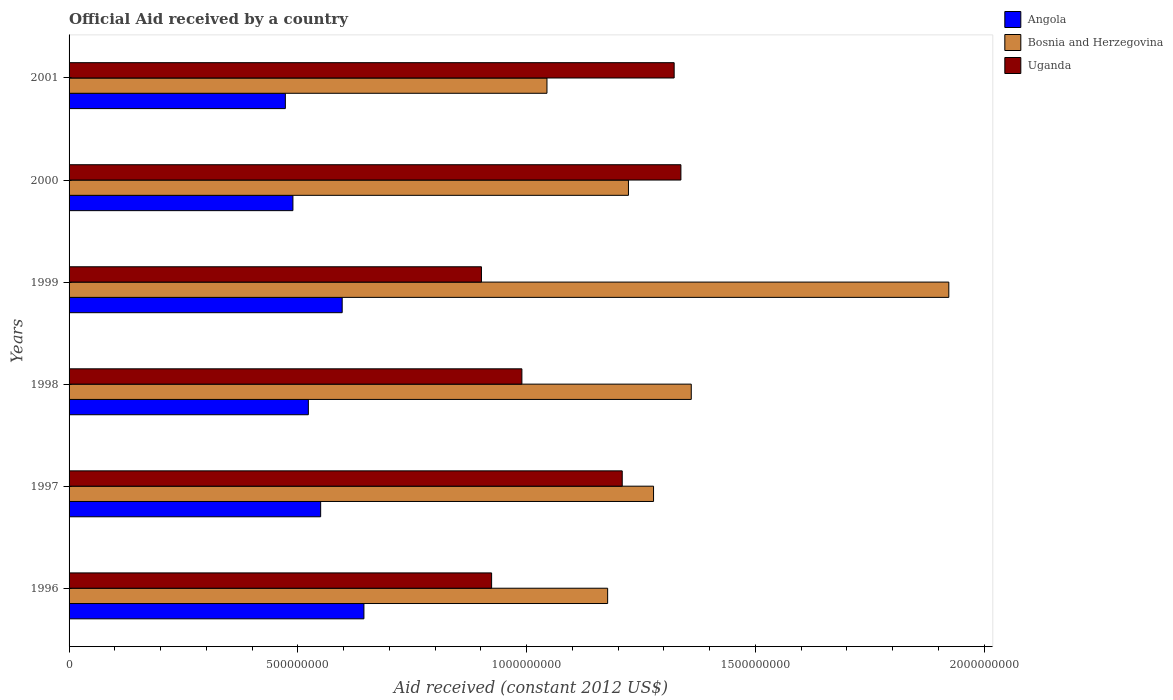How many different coloured bars are there?
Give a very brief answer. 3. How many groups of bars are there?
Keep it short and to the point. 6. Are the number of bars on each tick of the Y-axis equal?
Offer a terse response. Yes. What is the label of the 2nd group of bars from the top?
Your answer should be compact. 2000. What is the net official aid received in Bosnia and Herzegovina in 2001?
Your answer should be compact. 1.04e+09. Across all years, what is the maximum net official aid received in Uganda?
Your answer should be very brief. 1.34e+09. Across all years, what is the minimum net official aid received in Angola?
Give a very brief answer. 4.73e+08. In which year was the net official aid received in Bosnia and Herzegovina maximum?
Provide a succinct answer. 1999. What is the total net official aid received in Uganda in the graph?
Ensure brevity in your answer.  6.68e+09. What is the difference between the net official aid received in Uganda in 1996 and that in 2000?
Make the answer very short. -4.14e+08. What is the difference between the net official aid received in Bosnia and Herzegovina in 2000 and the net official aid received in Uganda in 1998?
Offer a terse response. 2.33e+08. What is the average net official aid received in Bosnia and Herzegovina per year?
Keep it short and to the point. 1.33e+09. In the year 1998, what is the difference between the net official aid received in Uganda and net official aid received in Bosnia and Herzegovina?
Your response must be concise. -3.70e+08. In how many years, is the net official aid received in Bosnia and Herzegovina greater than 900000000 US$?
Provide a short and direct response. 6. What is the ratio of the net official aid received in Uganda in 1998 to that in 2001?
Offer a terse response. 0.75. Is the difference between the net official aid received in Uganda in 1996 and 1999 greater than the difference between the net official aid received in Bosnia and Herzegovina in 1996 and 1999?
Keep it short and to the point. Yes. What is the difference between the highest and the second highest net official aid received in Angola?
Provide a succinct answer. 4.75e+07. What is the difference between the highest and the lowest net official aid received in Uganda?
Offer a very short reply. 4.36e+08. In how many years, is the net official aid received in Bosnia and Herzegovina greater than the average net official aid received in Bosnia and Herzegovina taken over all years?
Your answer should be very brief. 2. What does the 3rd bar from the top in 1997 represents?
Give a very brief answer. Angola. What does the 2nd bar from the bottom in 1997 represents?
Provide a short and direct response. Bosnia and Herzegovina. How many bars are there?
Keep it short and to the point. 18. Are the values on the major ticks of X-axis written in scientific E-notation?
Your response must be concise. No. Does the graph contain any zero values?
Your response must be concise. No. Does the graph contain grids?
Your answer should be very brief. No. How many legend labels are there?
Provide a short and direct response. 3. How are the legend labels stacked?
Give a very brief answer. Vertical. What is the title of the graph?
Make the answer very short. Official Aid received by a country. Does "Guinea" appear as one of the legend labels in the graph?
Your answer should be compact. No. What is the label or title of the X-axis?
Give a very brief answer. Aid received (constant 2012 US$). What is the Aid received (constant 2012 US$) in Angola in 1996?
Make the answer very short. 6.44e+08. What is the Aid received (constant 2012 US$) in Bosnia and Herzegovina in 1996?
Ensure brevity in your answer.  1.18e+09. What is the Aid received (constant 2012 US$) in Uganda in 1996?
Provide a succinct answer. 9.24e+08. What is the Aid received (constant 2012 US$) of Angola in 1997?
Your answer should be compact. 5.50e+08. What is the Aid received (constant 2012 US$) of Bosnia and Herzegovina in 1997?
Offer a very short reply. 1.28e+09. What is the Aid received (constant 2012 US$) in Uganda in 1997?
Make the answer very short. 1.21e+09. What is the Aid received (constant 2012 US$) in Angola in 1998?
Ensure brevity in your answer.  5.23e+08. What is the Aid received (constant 2012 US$) in Bosnia and Herzegovina in 1998?
Provide a short and direct response. 1.36e+09. What is the Aid received (constant 2012 US$) in Uganda in 1998?
Your answer should be compact. 9.90e+08. What is the Aid received (constant 2012 US$) in Angola in 1999?
Your answer should be compact. 5.97e+08. What is the Aid received (constant 2012 US$) of Bosnia and Herzegovina in 1999?
Your response must be concise. 1.92e+09. What is the Aid received (constant 2012 US$) of Uganda in 1999?
Your response must be concise. 9.01e+08. What is the Aid received (constant 2012 US$) of Angola in 2000?
Provide a short and direct response. 4.89e+08. What is the Aid received (constant 2012 US$) of Bosnia and Herzegovina in 2000?
Give a very brief answer. 1.22e+09. What is the Aid received (constant 2012 US$) of Uganda in 2000?
Provide a short and direct response. 1.34e+09. What is the Aid received (constant 2012 US$) of Angola in 2001?
Give a very brief answer. 4.73e+08. What is the Aid received (constant 2012 US$) of Bosnia and Herzegovina in 2001?
Provide a succinct answer. 1.04e+09. What is the Aid received (constant 2012 US$) in Uganda in 2001?
Keep it short and to the point. 1.32e+09. Across all years, what is the maximum Aid received (constant 2012 US$) of Angola?
Give a very brief answer. 6.44e+08. Across all years, what is the maximum Aid received (constant 2012 US$) of Bosnia and Herzegovina?
Give a very brief answer. 1.92e+09. Across all years, what is the maximum Aid received (constant 2012 US$) of Uganda?
Keep it short and to the point. 1.34e+09. Across all years, what is the minimum Aid received (constant 2012 US$) of Angola?
Offer a very short reply. 4.73e+08. Across all years, what is the minimum Aid received (constant 2012 US$) in Bosnia and Herzegovina?
Your answer should be compact. 1.04e+09. Across all years, what is the minimum Aid received (constant 2012 US$) in Uganda?
Offer a very short reply. 9.01e+08. What is the total Aid received (constant 2012 US$) in Angola in the graph?
Offer a terse response. 3.28e+09. What is the total Aid received (constant 2012 US$) in Bosnia and Herzegovina in the graph?
Your answer should be compact. 8.00e+09. What is the total Aid received (constant 2012 US$) of Uganda in the graph?
Make the answer very short. 6.68e+09. What is the difference between the Aid received (constant 2012 US$) in Angola in 1996 and that in 1997?
Ensure brevity in your answer.  9.46e+07. What is the difference between the Aid received (constant 2012 US$) in Bosnia and Herzegovina in 1996 and that in 1997?
Give a very brief answer. -1.00e+08. What is the difference between the Aid received (constant 2012 US$) of Uganda in 1996 and that in 1997?
Make the answer very short. -2.86e+08. What is the difference between the Aid received (constant 2012 US$) of Angola in 1996 and that in 1998?
Your answer should be compact. 1.21e+08. What is the difference between the Aid received (constant 2012 US$) in Bosnia and Herzegovina in 1996 and that in 1998?
Your answer should be very brief. -1.83e+08. What is the difference between the Aid received (constant 2012 US$) of Uganda in 1996 and that in 1998?
Provide a succinct answer. -6.62e+07. What is the difference between the Aid received (constant 2012 US$) of Angola in 1996 and that in 1999?
Give a very brief answer. 4.75e+07. What is the difference between the Aid received (constant 2012 US$) in Bosnia and Herzegovina in 1996 and that in 1999?
Keep it short and to the point. -7.46e+08. What is the difference between the Aid received (constant 2012 US$) of Uganda in 1996 and that in 1999?
Ensure brevity in your answer.  2.22e+07. What is the difference between the Aid received (constant 2012 US$) of Angola in 1996 and that in 2000?
Offer a terse response. 1.55e+08. What is the difference between the Aid received (constant 2012 US$) in Bosnia and Herzegovina in 1996 and that in 2000?
Your answer should be compact. -4.55e+07. What is the difference between the Aid received (constant 2012 US$) of Uganda in 1996 and that in 2000?
Keep it short and to the point. -4.14e+08. What is the difference between the Aid received (constant 2012 US$) in Angola in 1996 and that in 2001?
Offer a terse response. 1.72e+08. What is the difference between the Aid received (constant 2012 US$) of Bosnia and Herzegovina in 1996 and that in 2001?
Ensure brevity in your answer.  1.33e+08. What is the difference between the Aid received (constant 2012 US$) in Uganda in 1996 and that in 2001?
Ensure brevity in your answer.  -3.99e+08. What is the difference between the Aid received (constant 2012 US$) in Angola in 1997 and that in 1998?
Offer a terse response. 2.69e+07. What is the difference between the Aid received (constant 2012 US$) in Bosnia and Herzegovina in 1997 and that in 1998?
Keep it short and to the point. -8.25e+07. What is the difference between the Aid received (constant 2012 US$) in Uganda in 1997 and that in 1998?
Your answer should be very brief. 2.19e+08. What is the difference between the Aid received (constant 2012 US$) in Angola in 1997 and that in 1999?
Offer a very short reply. -4.71e+07. What is the difference between the Aid received (constant 2012 US$) in Bosnia and Herzegovina in 1997 and that in 1999?
Offer a terse response. -6.45e+08. What is the difference between the Aid received (constant 2012 US$) of Uganda in 1997 and that in 1999?
Keep it short and to the point. 3.08e+08. What is the difference between the Aid received (constant 2012 US$) in Angola in 1997 and that in 2000?
Provide a short and direct response. 6.06e+07. What is the difference between the Aid received (constant 2012 US$) of Bosnia and Herzegovina in 1997 and that in 2000?
Your response must be concise. 5.48e+07. What is the difference between the Aid received (constant 2012 US$) in Uganda in 1997 and that in 2000?
Make the answer very short. -1.28e+08. What is the difference between the Aid received (constant 2012 US$) of Angola in 1997 and that in 2001?
Your response must be concise. 7.72e+07. What is the difference between the Aid received (constant 2012 US$) in Bosnia and Herzegovina in 1997 and that in 2001?
Provide a succinct answer. 2.33e+08. What is the difference between the Aid received (constant 2012 US$) in Uganda in 1997 and that in 2001?
Offer a terse response. -1.14e+08. What is the difference between the Aid received (constant 2012 US$) of Angola in 1998 and that in 1999?
Offer a terse response. -7.39e+07. What is the difference between the Aid received (constant 2012 US$) in Bosnia and Herzegovina in 1998 and that in 1999?
Give a very brief answer. -5.63e+08. What is the difference between the Aid received (constant 2012 US$) of Uganda in 1998 and that in 1999?
Ensure brevity in your answer.  8.84e+07. What is the difference between the Aid received (constant 2012 US$) of Angola in 1998 and that in 2000?
Give a very brief answer. 3.38e+07. What is the difference between the Aid received (constant 2012 US$) of Bosnia and Herzegovina in 1998 and that in 2000?
Keep it short and to the point. 1.37e+08. What is the difference between the Aid received (constant 2012 US$) of Uganda in 1998 and that in 2000?
Make the answer very short. -3.48e+08. What is the difference between the Aid received (constant 2012 US$) of Angola in 1998 and that in 2001?
Ensure brevity in your answer.  5.03e+07. What is the difference between the Aid received (constant 2012 US$) of Bosnia and Herzegovina in 1998 and that in 2001?
Your answer should be compact. 3.15e+08. What is the difference between the Aid received (constant 2012 US$) of Uganda in 1998 and that in 2001?
Your answer should be compact. -3.33e+08. What is the difference between the Aid received (constant 2012 US$) of Angola in 1999 and that in 2000?
Give a very brief answer. 1.08e+08. What is the difference between the Aid received (constant 2012 US$) in Bosnia and Herzegovina in 1999 and that in 2000?
Provide a succinct answer. 7.00e+08. What is the difference between the Aid received (constant 2012 US$) of Uganda in 1999 and that in 2000?
Offer a very short reply. -4.36e+08. What is the difference between the Aid received (constant 2012 US$) of Angola in 1999 and that in 2001?
Offer a very short reply. 1.24e+08. What is the difference between the Aid received (constant 2012 US$) in Bosnia and Herzegovina in 1999 and that in 2001?
Give a very brief answer. 8.78e+08. What is the difference between the Aid received (constant 2012 US$) in Uganda in 1999 and that in 2001?
Provide a short and direct response. -4.21e+08. What is the difference between the Aid received (constant 2012 US$) in Angola in 2000 and that in 2001?
Give a very brief answer. 1.65e+07. What is the difference between the Aid received (constant 2012 US$) in Bosnia and Herzegovina in 2000 and that in 2001?
Offer a very short reply. 1.78e+08. What is the difference between the Aid received (constant 2012 US$) in Uganda in 2000 and that in 2001?
Ensure brevity in your answer.  1.48e+07. What is the difference between the Aid received (constant 2012 US$) of Angola in 1996 and the Aid received (constant 2012 US$) of Bosnia and Herzegovina in 1997?
Give a very brief answer. -6.33e+08. What is the difference between the Aid received (constant 2012 US$) in Angola in 1996 and the Aid received (constant 2012 US$) in Uganda in 1997?
Provide a short and direct response. -5.65e+08. What is the difference between the Aid received (constant 2012 US$) in Bosnia and Herzegovina in 1996 and the Aid received (constant 2012 US$) in Uganda in 1997?
Your answer should be very brief. -3.19e+07. What is the difference between the Aid received (constant 2012 US$) of Angola in 1996 and the Aid received (constant 2012 US$) of Bosnia and Herzegovina in 1998?
Ensure brevity in your answer.  -7.16e+08. What is the difference between the Aid received (constant 2012 US$) in Angola in 1996 and the Aid received (constant 2012 US$) in Uganda in 1998?
Provide a short and direct response. -3.45e+08. What is the difference between the Aid received (constant 2012 US$) in Bosnia and Herzegovina in 1996 and the Aid received (constant 2012 US$) in Uganda in 1998?
Provide a short and direct response. 1.87e+08. What is the difference between the Aid received (constant 2012 US$) of Angola in 1996 and the Aid received (constant 2012 US$) of Bosnia and Herzegovina in 1999?
Your answer should be very brief. -1.28e+09. What is the difference between the Aid received (constant 2012 US$) in Angola in 1996 and the Aid received (constant 2012 US$) in Uganda in 1999?
Your response must be concise. -2.57e+08. What is the difference between the Aid received (constant 2012 US$) of Bosnia and Herzegovina in 1996 and the Aid received (constant 2012 US$) of Uganda in 1999?
Your answer should be very brief. 2.76e+08. What is the difference between the Aid received (constant 2012 US$) of Angola in 1996 and the Aid received (constant 2012 US$) of Bosnia and Herzegovina in 2000?
Ensure brevity in your answer.  -5.78e+08. What is the difference between the Aid received (constant 2012 US$) of Angola in 1996 and the Aid received (constant 2012 US$) of Uganda in 2000?
Make the answer very short. -6.93e+08. What is the difference between the Aid received (constant 2012 US$) of Bosnia and Herzegovina in 1996 and the Aid received (constant 2012 US$) of Uganda in 2000?
Ensure brevity in your answer.  -1.60e+08. What is the difference between the Aid received (constant 2012 US$) in Angola in 1996 and the Aid received (constant 2012 US$) in Bosnia and Herzegovina in 2001?
Make the answer very short. -4.00e+08. What is the difference between the Aid received (constant 2012 US$) of Angola in 1996 and the Aid received (constant 2012 US$) of Uganda in 2001?
Make the answer very short. -6.78e+08. What is the difference between the Aid received (constant 2012 US$) in Bosnia and Herzegovina in 1996 and the Aid received (constant 2012 US$) in Uganda in 2001?
Your answer should be very brief. -1.45e+08. What is the difference between the Aid received (constant 2012 US$) in Angola in 1997 and the Aid received (constant 2012 US$) in Bosnia and Herzegovina in 1998?
Your response must be concise. -8.10e+08. What is the difference between the Aid received (constant 2012 US$) of Angola in 1997 and the Aid received (constant 2012 US$) of Uganda in 1998?
Your answer should be very brief. -4.40e+08. What is the difference between the Aid received (constant 2012 US$) of Bosnia and Herzegovina in 1997 and the Aid received (constant 2012 US$) of Uganda in 1998?
Offer a terse response. 2.88e+08. What is the difference between the Aid received (constant 2012 US$) of Angola in 1997 and the Aid received (constant 2012 US$) of Bosnia and Herzegovina in 1999?
Provide a short and direct response. -1.37e+09. What is the difference between the Aid received (constant 2012 US$) of Angola in 1997 and the Aid received (constant 2012 US$) of Uganda in 1999?
Keep it short and to the point. -3.51e+08. What is the difference between the Aid received (constant 2012 US$) of Bosnia and Herzegovina in 1997 and the Aid received (constant 2012 US$) of Uganda in 1999?
Your answer should be very brief. 3.76e+08. What is the difference between the Aid received (constant 2012 US$) in Angola in 1997 and the Aid received (constant 2012 US$) in Bosnia and Herzegovina in 2000?
Offer a terse response. -6.73e+08. What is the difference between the Aid received (constant 2012 US$) in Angola in 1997 and the Aid received (constant 2012 US$) in Uganda in 2000?
Make the answer very short. -7.87e+08. What is the difference between the Aid received (constant 2012 US$) in Bosnia and Herzegovina in 1997 and the Aid received (constant 2012 US$) in Uganda in 2000?
Your response must be concise. -5.98e+07. What is the difference between the Aid received (constant 2012 US$) of Angola in 1997 and the Aid received (constant 2012 US$) of Bosnia and Herzegovina in 2001?
Offer a very short reply. -4.95e+08. What is the difference between the Aid received (constant 2012 US$) in Angola in 1997 and the Aid received (constant 2012 US$) in Uganda in 2001?
Your response must be concise. -7.73e+08. What is the difference between the Aid received (constant 2012 US$) in Bosnia and Herzegovina in 1997 and the Aid received (constant 2012 US$) in Uganda in 2001?
Provide a short and direct response. -4.51e+07. What is the difference between the Aid received (constant 2012 US$) of Angola in 1998 and the Aid received (constant 2012 US$) of Bosnia and Herzegovina in 1999?
Give a very brief answer. -1.40e+09. What is the difference between the Aid received (constant 2012 US$) of Angola in 1998 and the Aid received (constant 2012 US$) of Uganda in 1999?
Provide a succinct answer. -3.78e+08. What is the difference between the Aid received (constant 2012 US$) of Bosnia and Herzegovina in 1998 and the Aid received (constant 2012 US$) of Uganda in 1999?
Offer a terse response. 4.59e+08. What is the difference between the Aid received (constant 2012 US$) in Angola in 1998 and the Aid received (constant 2012 US$) in Bosnia and Herzegovina in 2000?
Provide a succinct answer. -7.00e+08. What is the difference between the Aid received (constant 2012 US$) in Angola in 1998 and the Aid received (constant 2012 US$) in Uganda in 2000?
Make the answer very short. -8.14e+08. What is the difference between the Aid received (constant 2012 US$) in Bosnia and Herzegovina in 1998 and the Aid received (constant 2012 US$) in Uganda in 2000?
Provide a short and direct response. 2.26e+07. What is the difference between the Aid received (constant 2012 US$) of Angola in 1998 and the Aid received (constant 2012 US$) of Bosnia and Herzegovina in 2001?
Your answer should be very brief. -5.22e+08. What is the difference between the Aid received (constant 2012 US$) in Angola in 1998 and the Aid received (constant 2012 US$) in Uganda in 2001?
Provide a short and direct response. -8.00e+08. What is the difference between the Aid received (constant 2012 US$) in Bosnia and Herzegovina in 1998 and the Aid received (constant 2012 US$) in Uganda in 2001?
Provide a succinct answer. 3.74e+07. What is the difference between the Aid received (constant 2012 US$) in Angola in 1999 and the Aid received (constant 2012 US$) in Bosnia and Herzegovina in 2000?
Give a very brief answer. -6.26e+08. What is the difference between the Aid received (constant 2012 US$) of Angola in 1999 and the Aid received (constant 2012 US$) of Uganda in 2000?
Your answer should be compact. -7.40e+08. What is the difference between the Aid received (constant 2012 US$) in Bosnia and Herzegovina in 1999 and the Aid received (constant 2012 US$) in Uganda in 2000?
Provide a succinct answer. 5.86e+08. What is the difference between the Aid received (constant 2012 US$) in Angola in 1999 and the Aid received (constant 2012 US$) in Bosnia and Herzegovina in 2001?
Make the answer very short. -4.48e+08. What is the difference between the Aid received (constant 2012 US$) of Angola in 1999 and the Aid received (constant 2012 US$) of Uganda in 2001?
Offer a terse response. -7.26e+08. What is the difference between the Aid received (constant 2012 US$) in Bosnia and Herzegovina in 1999 and the Aid received (constant 2012 US$) in Uganda in 2001?
Provide a short and direct response. 6.00e+08. What is the difference between the Aid received (constant 2012 US$) of Angola in 2000 and the Aid received (constant 2012 US$) of Bosnia and Herzegovina in 2001?
Provide a short and direct response. -5.55e+08. What is the difference between the Aid received (constant 2012 US$) in Angola in 2000 and the Aid received (constant 2012 US$) in Uganda in 2001?
Offer a terse response. -8.33e+08. What is the difference between the Aid received (constant 2012 US$) of Bosnia and Herzegovina in 2000 and the Aid received (constant 2012 US$) of Uganda in 2001?
Give a very brief answer. -9.99e+07. What is the average Aid received (constant 2012 US$) in Angola per year?
Your answer should be compact. 5.46e+08. What is the average Aid received (constant 2012 US$) of Bosnia and Herzegovina per year?
Your answer should be compact. 1.33e+09. What is the average Aid received (constant 2012 US$) of Uganda per year?
Offer a terse response. 1.11e+09. In the year 1996, what is the difference between the Aid received (constant 2012 US$) of Angola and Aid received (constant 2012 US$) of Bosnia and Herzegovina?
Offer a very short reply. -5.33e+08. In the year 1996, what is the difference between the Aid received (constant 2012 US$) in Angola and Aid received (constant 2012 US$) in Uganda?
Provide a succinct answer. -2.79e+08. In the year 1996, what is the difference between the Aid received (constant 2012 US$) of Bosnia and Herzegovina and Aid received (constant 2012 US$) of Uganda?
Keep it short and to the point. 2.54e+08. In the year 1997, what is the difference between the Aid received (constant 2012 US$) of Angola and Aid received (constant 2012 US$) of Bosnia and Herzegovina?
Your answer should be compact. -7.28e+08. In the year 1997, what is the difference between the Aid received (constant 2012 US$) in Angola and Aid received (constant 2012 US$) in Uganda?
Keep it short and to the point. -6.59e+08. In the year 1997, what is the difference between the Aid received (constant 2012 US$) in Bosnia and Herzegovina and Aid received (constant 2012 US$) in Uganda?
Your answer should be compact. 6.84e+07. In the year 1998, what is the difference between the Aid received (constant 2012 US$) of Angola and Aid received (constant 2012 US$) of Bosnia and Herzegovina?
Offer a terse response. -8.37e+08. In the year 1998, what is the difference between the Aid received (constant 2012 US$) in Angola and Aid received (constant 2012 US$) in Uganda?
Ensure brevity in your answer.  -4.67e+08. In the year 1998, what is the difference between the Aid received (constant 2012 US$) of Bosnia and Herzegovina and Aid received (constant 2012 US$) of Uganda?
Offer a very short reply. 3.70e+08. In the year 1999, what is the difference between the Aid received (constant 2012 US$) in Angola and Aid received (constant 2012 US$) in Bosnia and Herzegovina?
Your answer should be very brief. -1.33e+09. In the year 1999, what is the difference between the Aid received (constant 2012 US$) of Angola and Aid received (constant 2012 US$) of Uganda?
Make the answer very short. -3.04e+08. In the year 1999, what is the difference between the Aid received (constant 2012 US$) of Bosnia and Herzegovina and Aid received (constant 2012 US$) of Uganda?
Your answer should be compact. 1.02e+09. In the year 2000, what is the difference between the Aid received (constant 2012 US$) of Angola and Aid received (constant 2012 US$) of Bosnia and Herzegovina?
Give a very brief answer. -7.33e+08. In the year 2000, what is the difference between the Aid received (constant 2012 US$) of Angola and Aid received (constant 2012 US$) of Uganda?
Your answer should be compact. -8.48e+08. In the year 2000, what is the difference between the Aid received (constant 2012 US$) of Bosnia and Herzegovina and Aid received (constant 2012 US$) of Uganda?
Give a very brief answer. -1.15e+08. In the year 2001, what is the difference between the Aid received (constant 2012 US$) of Angola and Aid received (constant 2012 US$) of Bosnia and Herzegovina?
Your response must be concise. -5.72e+08. In the year 2001, what is the difference between the Aid received (constant 2012 US$) of Angola and Aid received (constant 2012 US$) of Uganda?
Your response must be concise. -8.50e+08. In the year 2001, what is the difference between the Aid received (constant 2012 US$) in Bosnia and Herzegovina and Aid received (constant 2012 US$) in Uganda?
Keep it short and to the point. -2.78e+08. What is the ratio of the Aid received (constant 2012 US$) of Angola in 1996 to that in 1997?
Offer a terse response. 1.17. What is the ratio of the Aid received (constant 2012 US$) of Bosnia and Herzegovina in 1996 to that in 1997?
Keep it short and to the point. 0.92. What is the ratio of the Aid received (constant 2012 US$) in Uganda in 1996 to that in 1997?
Give a very brief answer. 0.76. What is the ratio of the Aid received (constant 2012 US$) in Angola in 1996 to that in 1998?
Offer a terse response. 1.23. What is the ratio of the Aid received (constant 2012 US$) of Bosnia and Herzegovina in 1996 to that in 1998?
Provide a succinct answer. 0.87. What is the ratio of the Aid received (constant 2012 US$) of Uganda in 1996 to that in 1998?
Make the answer very short. 0.93. What is the ratio of the Aid received (constant 2012 US$) in Angola in 1996 to that in 1999?
Make the answer very short. 1.08. What is the ratio of the Aid received (constant 2012 US$) in Bosnia and Herzegovina in 1996 to that in 1999?
Keep it short and to the point. 0.61. What is the ratio of the Aid received (constant 2012 US$) of Uganda in 1996 to that in 1999?
Provide a short and direct response. 1.02. What is the ratio of the Aid received (constant 2012 US$) of Angola in 1996 to that in 2000?
Offer a terse response. 1.32. What is the ratio of the Aid received (constant 2012 US$) in Bosnia and Herzegovina in 1996 to that in 2000?
Make the answer very short. 0.96. What is the ratio of the Aid received (constant 2012 US$) in Uganda in 1996 to that in 2000?
Your response must be concise. 0.69. What is the ratio of the Aid received (constant 2012 US$) in Angola in 1996 to that in 2001?
Your answer should be very brief. 1.36. What is the ratio of the Aid received (constant 2012 US$) in Bosnia and Herzegovina in 1996 to that in 2001?
Provide a short and direct response. 1.13. What is the ratio of the Aid received (constant 2012 US$) in Uganda in 1996 to that in 2001?
Give a very brief answer. 0.7. What is the ratio of the Aid received (constant 2012 US$) in Angola in 1997 to that in 1998?
Ensure brevity in your answer.  1.05. What is the ratio of the Aid received (constant 2012 US$) of Bosnia and Herzegovina in 1997 to that in 1998?
Keep it short and to the point. 0.94. What is the ratio of the Aid received (constant 2012 US$) of Uganda in 1997 to that in 1998?
Provide a short and direct response. 1.22. What is the ratio of the Aid received (constant 2012 US$) in Angola in 1997 to that in 1999?
Offer a terse response. 0.92. What is the ratio of the Aid received (constant 2012 US$) in Bosnia and Herzegovina in 1997 to that in 1999?
Your answer should be very brief. 0.66. What is the ratio of the Aid received (constant 2012 US$) in Uganda in 1997 to that in 1999?
Provide a succinct answer. 1.34. What is the ratio of the Aid received (constant 2012 US$) of Angola in 1997 to that in 2000?
Ensure brevity in your answer.  1.12. What is the ratio of the Aid received (constant 2012 US$) in Bosnia and Herzegovina in 1997 to that in 2000?
Ensure brevity in your answer.  1.04. What is the ratio of the Aid received (constant 2012 US$) in Uganda in 1997 to that in 2000?
Provide a succinct answer. 0.9. What is the ratio of the Aid received (constant 2012 US$) of Angola in 1997 to that in 2001?
Your answer should be compact. 1.16. What is the ratio of the Aid received (constant 2012 US$) of Bosnia and Herzegovina in 1997 to that in 2001?
Make the answer very short. 1.22. What is the ratio of the Aid received (constant 2012 US$) in Uganda in 1997 to that in 2001?
Keep it short and to the point. 0.91. What is the ratio of the Aid received (constant 2012 US$) in Angola in 1998 to that in 1999?
Offer a very short reply. 0.88. What is the ratio of the Aid received (constant 2012 US$) of Bosnia and Herzegovina in 1998 to that in 1999?
Make the answer very short. 0.71. What is the ratio of the Aid received (constant 2012 US$) in Uganda in 1998 to that in 1999?
Give a very brief answer. 1.1. What is the ratio of the Aid received (constant 2012 US$) in Angola in 1998 to that in 2000?
Your response must be concise. 1.07. What is the ratio of the Aid received (constant 2012 US$) in Bosnia and Herzegovina in 1998 to that in 2000?
Provide a short and direct response. 1.11. What is the ratio of the Aid received (constant 2012 US$) in Uganda in 1998 to that in 2000?
Your answer should be compact. 0.74. What is the ratio of the Aid received (constant 2012 US$) in Angola in 1998 to that in 2001?
Provide a short and direct response. 1.11. What is the ratio of the Aid received (constant 2012 US$) of Bosnia and Herzegovina in 1998 to that in 2001?
Provide a short and direct response. 1.3. What is the ratio of the Aid received (constant 2012 US$) in Uganda in 1998 to that in 2001?
Provide a succinct answer. 0.75. What is the ratio of the Aid received (constant 2012 US$) in Angola in 1999 to that in 2000?
Keep it short and to the point. 1.22. What is the ratio of the Aid received (constant 2012 US$) in Bosnia and Herzegovina in 1999 to that in 2000?
Give a very brief answer. 1.57. What is the ratio of the Aid received (constant 2012 US$) in Uganda in 1999 to that in 2000?
Your answer should be very brief. 0.67. What is the ratio of the Aid received (constant 2012 US$) of Angola in 1999 to that in 2001?
Provide a succinct answer. 1.26. What is the ratio of the Aid received (constant 2012 US$) in Bosnia and Herzegovina in 1999 to that in 2001?
Provide a short and direct response. 1.84. What is the ratio of the Aid received (constant 2012 US$) of Uganda in 1999 to that in 2001?
Provide a short and direct response. 0.68. What is the ratio of the Aid received (constant 2012 US$) of Angola in 2000 to that in 2001?
Your answer should be compact. 1.03. What is the ratio of the Aid received (constant 2012 US$) in Bosnia and Herzegovina in 2000 to that in 2001?
Your answer should be compact. 1.17. What is the ratio of the Aid received (constant 2012 US$) of Uganda in 2000 to that in 2001?
Your answer should be compact. 1.01. What is the difference between the highest and the second highest Aid received (constant 2012 US$) of Angola?
Keep it short and to the point. 4.75e+07. What is the difference between the highest and the second highest Aid received (constant 2012 US$) of Bosnia and Herzegovina?
Offer a very short reply. 5.63e+08. What is the difference between the highest and the second highest Aid received (constant 2012 US$) of Uganda?
Your answer should be compact. 1.48e+07. What is the difference between the highest and the lowest Aid received (constant 2012 US$) of Angola?
Give a very brief answer. 1.72e+08. What is the difference between the highest and the lowest Aid received (constant 2012 US$) of Bosnia and Herzegovina?
Your answer should be very brief. 8.78e+08. What is the difference between the highest and the lowest Aid received (constant 2012 US$) in Uganda?
Provide a short and direct response. 4.36e+08. 